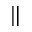<formula> <loc_0><loc_0><loc_500><loc_500>\|</formula> 